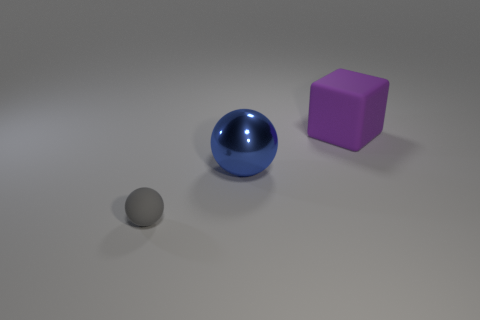Is there anything else that has the same size as the gray rubber thing?
Your answer should be very brief. No. There is a matte object that is on the left side of the big metal object; what is its size?
Ensure brevity in your answer.  Small. There is a matte thing left of the block; does it have the same size as the blue metallic sphere?
Keep it short and to the point. No. How many purple matte things are the same size as the gray matte sphere?
Make the answer very short. 0. Does the large shiny sphere have the same color as the rubber block?
Keep it short and to the point. No. The large blue metal thing is what shape?
Your response must be concise. Sphere. Is there a matte thing of the same color as the large matte block?
Your answer should be compact. No. Is the number of purple cubes that are in front of the small gray object greater than the number of large matte cubes?
Offer a very short reply. No. Is the shape of the large blue object the same as the thing that is behind the blue object?
Your response must be concise. No. Is there a tiny green cube?
Offer a terse response. No. 